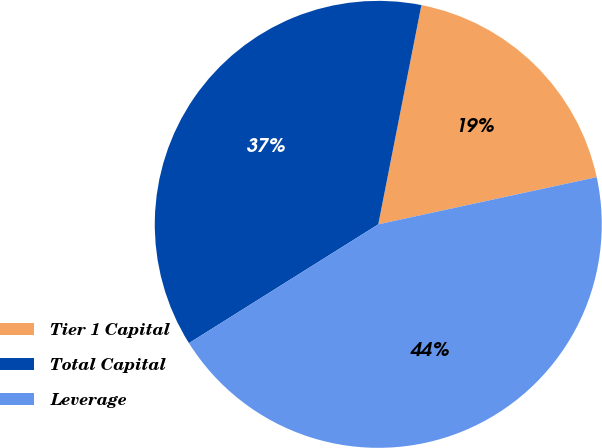<chart> <loc_0><loc_0><loc_500><loc_500><pie_chart><fcel>Tier 1 Capital<fcel>Total Capital<fcel>Leverage<nl><fcel>18.52%<fcel>37.01%<fcel>44.47%<nl></chart> 